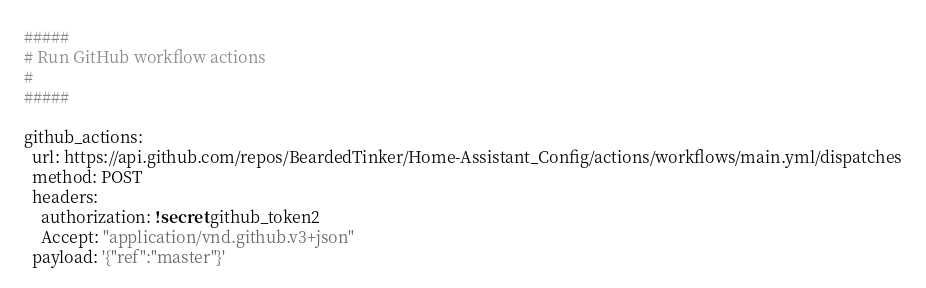Convert code to text. <code><loc_0><loc_0><loc_500><loc_500><_YAML_>#####
# Run GitHub workflow actions
#
#####

github_actions:
  url: https://api.github.com/repos/BeardedTinker/Home-Assistant_Config/actions/workflows/main.yml/dispatches
  method: POST
  headers:
    authorization: !secret github_token2
    Accept: "application/vnd.github.v3+json"
  payload: '{"ref":"master"}'</code> 